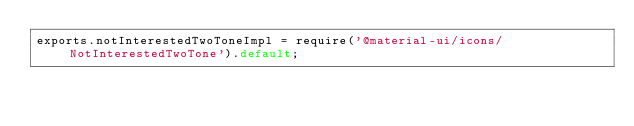<code> <loc_0><loc_0><loc_500><loc_500><_JavaScript_>exports.notInterestedTwoToneImpl = require('@material-ui/icons/NotInterestedTwoTone').default;
</code> 